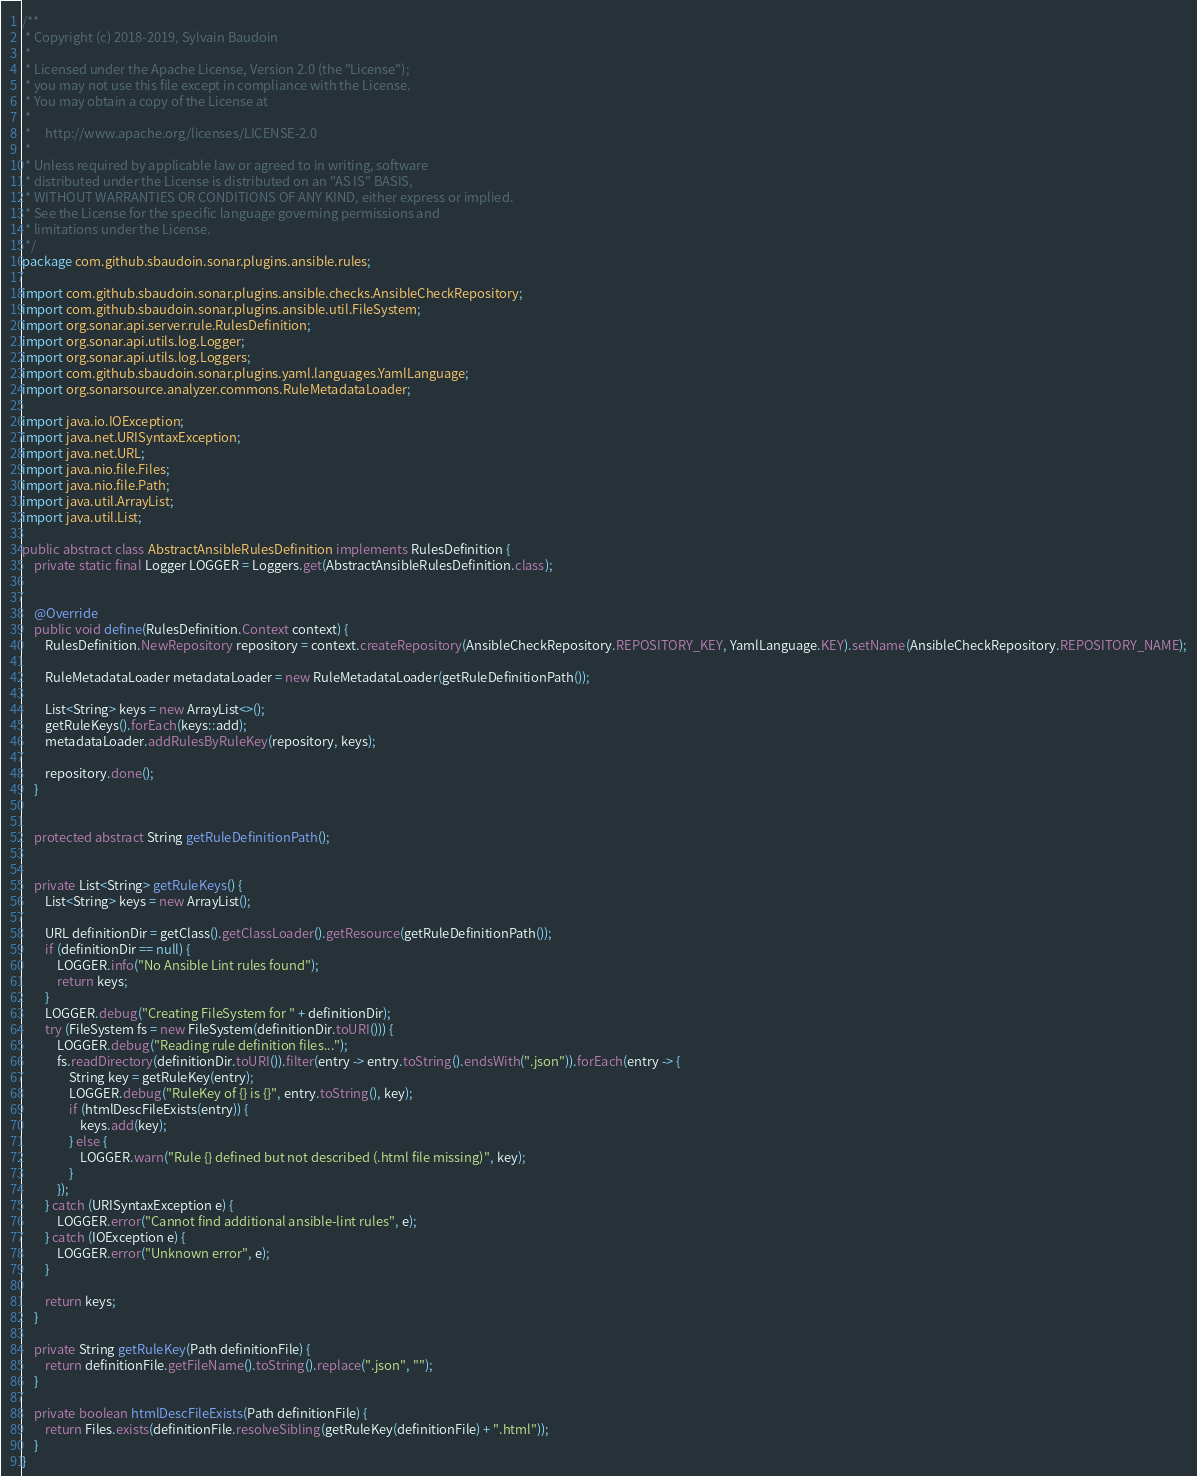Convert code to text. <code><loc_0><loc_0><loc_500><loc_500><_Java_>/**
 * Copyright (c) 2018-2019, Sylvain Baudoin
 *
 * Licensed under the Apache License, Version 2.0 (the "License");
 * you may not use this file except in compliance with the License.
 * You may obtain a copy of the License at
 *
 *     http://www.apache.org/licenses/LICENSE-2.0
 *
 * Unless required by applicable law or agreed to in writing, software
 * distributed under the License is distributed on an "AS IS" BASIS,
 * WITHOUT WARRANTIES OR CONDITIONS OF ANY KIND, either express or implied.
 * See the License for the specific language governing permissions and
 * limitations under the License.
 */
package com.github.sbaudoin.sonar.plugins.ansible.rules;

import com.github.sbaudoin.sonar.plugins.ansible.checks.AnsibleCheckRepository;
import com.github.sbaudoin.sonar.plugins.ansible.util.FileSystem;
import org.sonar.api.server.rule.RulesDefinition;
import org.sonar.api.utils.log.Logger;
import org.sonar.api.utils.log.Loggers;
import com.github.sbaudoin.sonar.plugins.yaml.languages.YamlLanguage;
import org.sonarsource.analyzer.commons.RuleMetadataLoader;

import java.io.IOException;
import java.net.URISyntaxException;
import java.net.URL;
import java.nio.file.Files;
import java.nio.file.Path;
import java.util.ArrayList;
import java.util.List;

public abstract class AbstractAnsibleRulesDefinition implements RulesDefinition {
    private static final Logger LOGGER = Loggers.get(AbstractAnsibleRulesDefinition.class);


    @Override
    public void define(RulesDefinition.Context context) {
        RulesDefinition.NewRepository repository = context.createRepository(AnsibleCheckRepository.REPOSITORY_KEY, YamlLanguage.KEY).setName(AnsibleCheckRepository.REPOSITORY_NAME);

        RuleMetadataLoader metadataLoader = new RuleMetadataLoader(getRuleDefinitionPath());

        List<String> keys = new ArrayList<>();
        getRuleKeys().forEach(keys::add);
        metadataLoader.addRulesByRuleKey(repository, keys);

        repository.done();
    }


    protected abstract String getRuleDefinitionPath();


    private List<String> getRuleKeys() {
        List<String> keys = new ArrayList();

        URL definitionDir = getClass().getClassLoader().getResource(getRuleDefinitionPath());
        if (definitionDir == null) {
            LOGGER.info("No Ansible Lint rules found");
            return keys;
        }
        LOGGER.debug("Creating FileSystem for " + definitionDir);
        try (FileSystem fs = new FileSystem(definitionDir.toURI())) {
            LOGGER.debug("Reading rule definition files...");
            fs.readDirectory(definitionDir.toURI()).filter(entry -> entry.toString().endsWith(".json")).forEach(entry -> {
                String key = getRuleKey(entry);
                LOGGER.debug("RuleKey of {} is {}", entry.toString(), key);
                if (htmlDescFileExists(entry)) {
                    keys.add(key);
                } else {
                    LOGGER.warn("Rule {} defined but not described (.html file missing)", key);
                }
            });
        } catch (URISyntaxException e) {
            LOGGER.error("Cannot find additional ansible-lint rules", e);
        } catch (IOException e) {
            LOGGER.error("Unknown error", e);
        }

        return keys;
    }

    private String getRuleKey(Path definitionFile) {
        return definitionFile.getFileName().toString().replace(".json", "");
    }

    private boolean htmlDescFileExists(Path definitionFile) {
        return Files.exists(definitionFile.resolveSibling(getRuleKey(definitionFile) + ".html"));
    }
}
</code> 